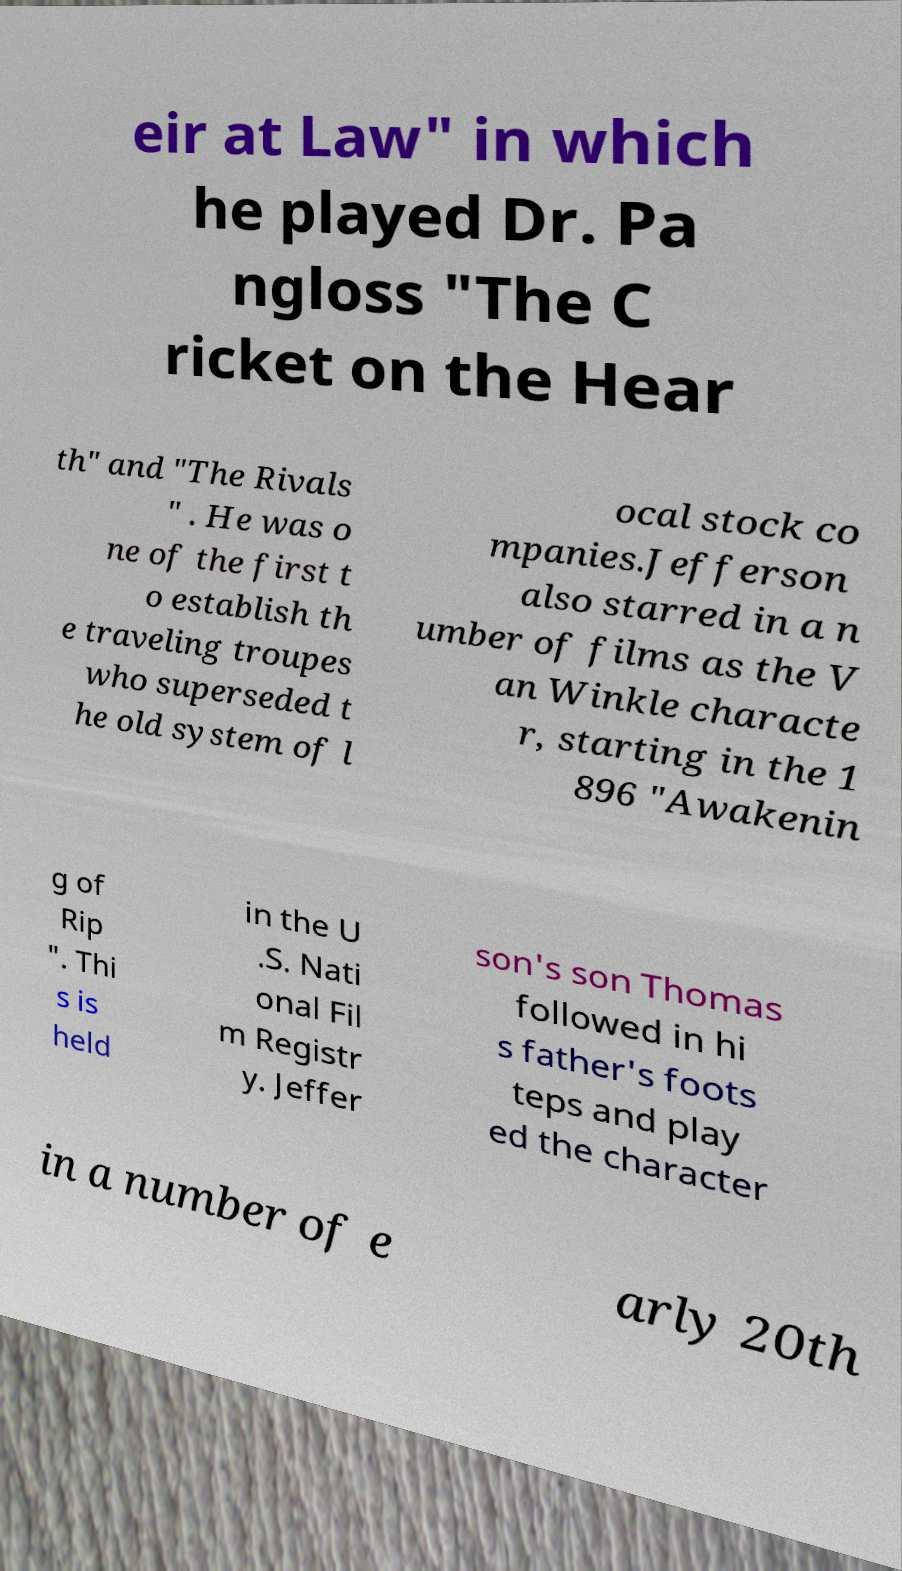Could you assist in decoding the text presented in this image and type it out clearly? eir at Law" in which he played Dr. Pa ngloss "The C ricket on the Hear th" and "The Rivals " . He was o ne of the first t o establish th e traveling troupes who superseded t he old system of l ocal stock co mpanies.Jefferson also starred in a n umber of films as the V an Winkle characte r, starting in the 1 896 "Awakenin g of Rip ". Thi s is held in the U .S. Nati onal Fil m Registr y. Jeffer son's son Thomas followed in hi s father's foots teps and play ed the character in a number of e arly 20th 